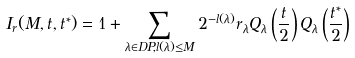<formula> <loc_0><loc_0><loc_500><loc_500>I _ { r } ( M , { t } , { t ^ { * } } ) = 1 + \sum _ { \lambda \in D P , l ( \lambda ) \leq M } 2 ^ { - l ( { \lambda } ) } r _ { \lambda } Q _ { \lambda } \left ( \frac { t } { 2 } \right ) Q _ { \lambda } \left ( \frac { { t } ^ { * } } { 2 } \right )</formula> 